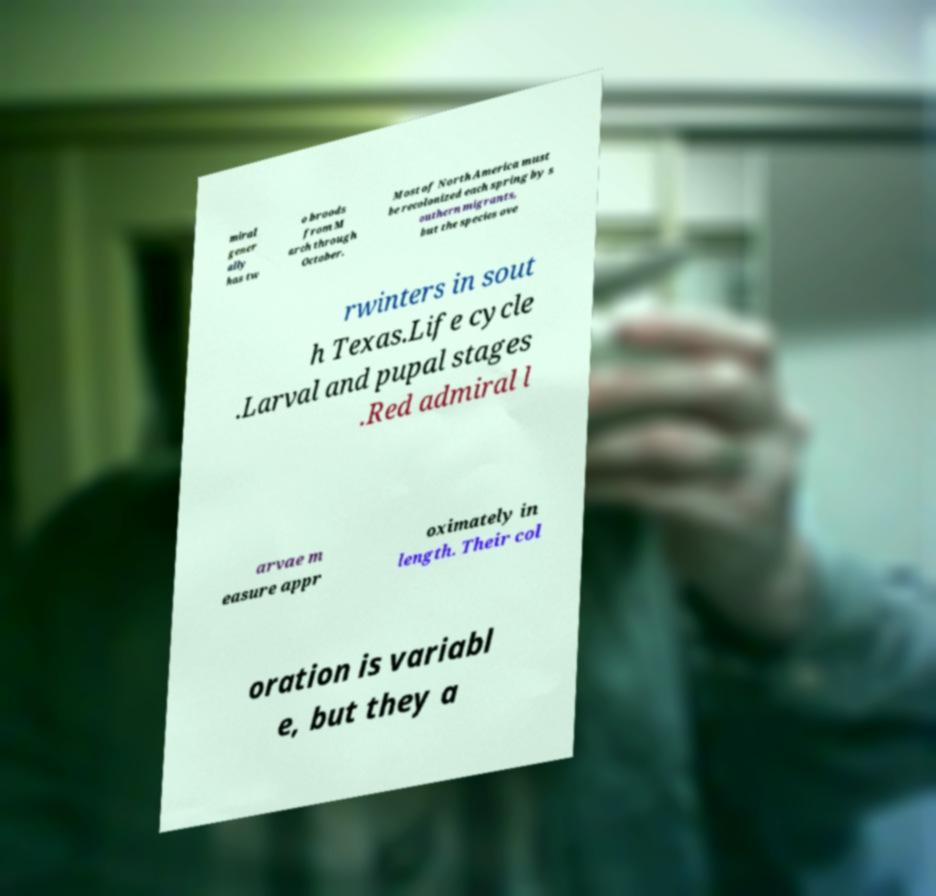For documentation purposes, I need the text within this image transcribed. Could you provide that? miral gener ally has tw o broods from M arch through October. Most of North America must be recolonized each spring by s outhern migrants, but the species ove rwinters in sout h Texas.Life cycle .Larval and pupal stages .Red admiral l arvae m easure appr oximately in length. Their col oration is variabl e, but they a 